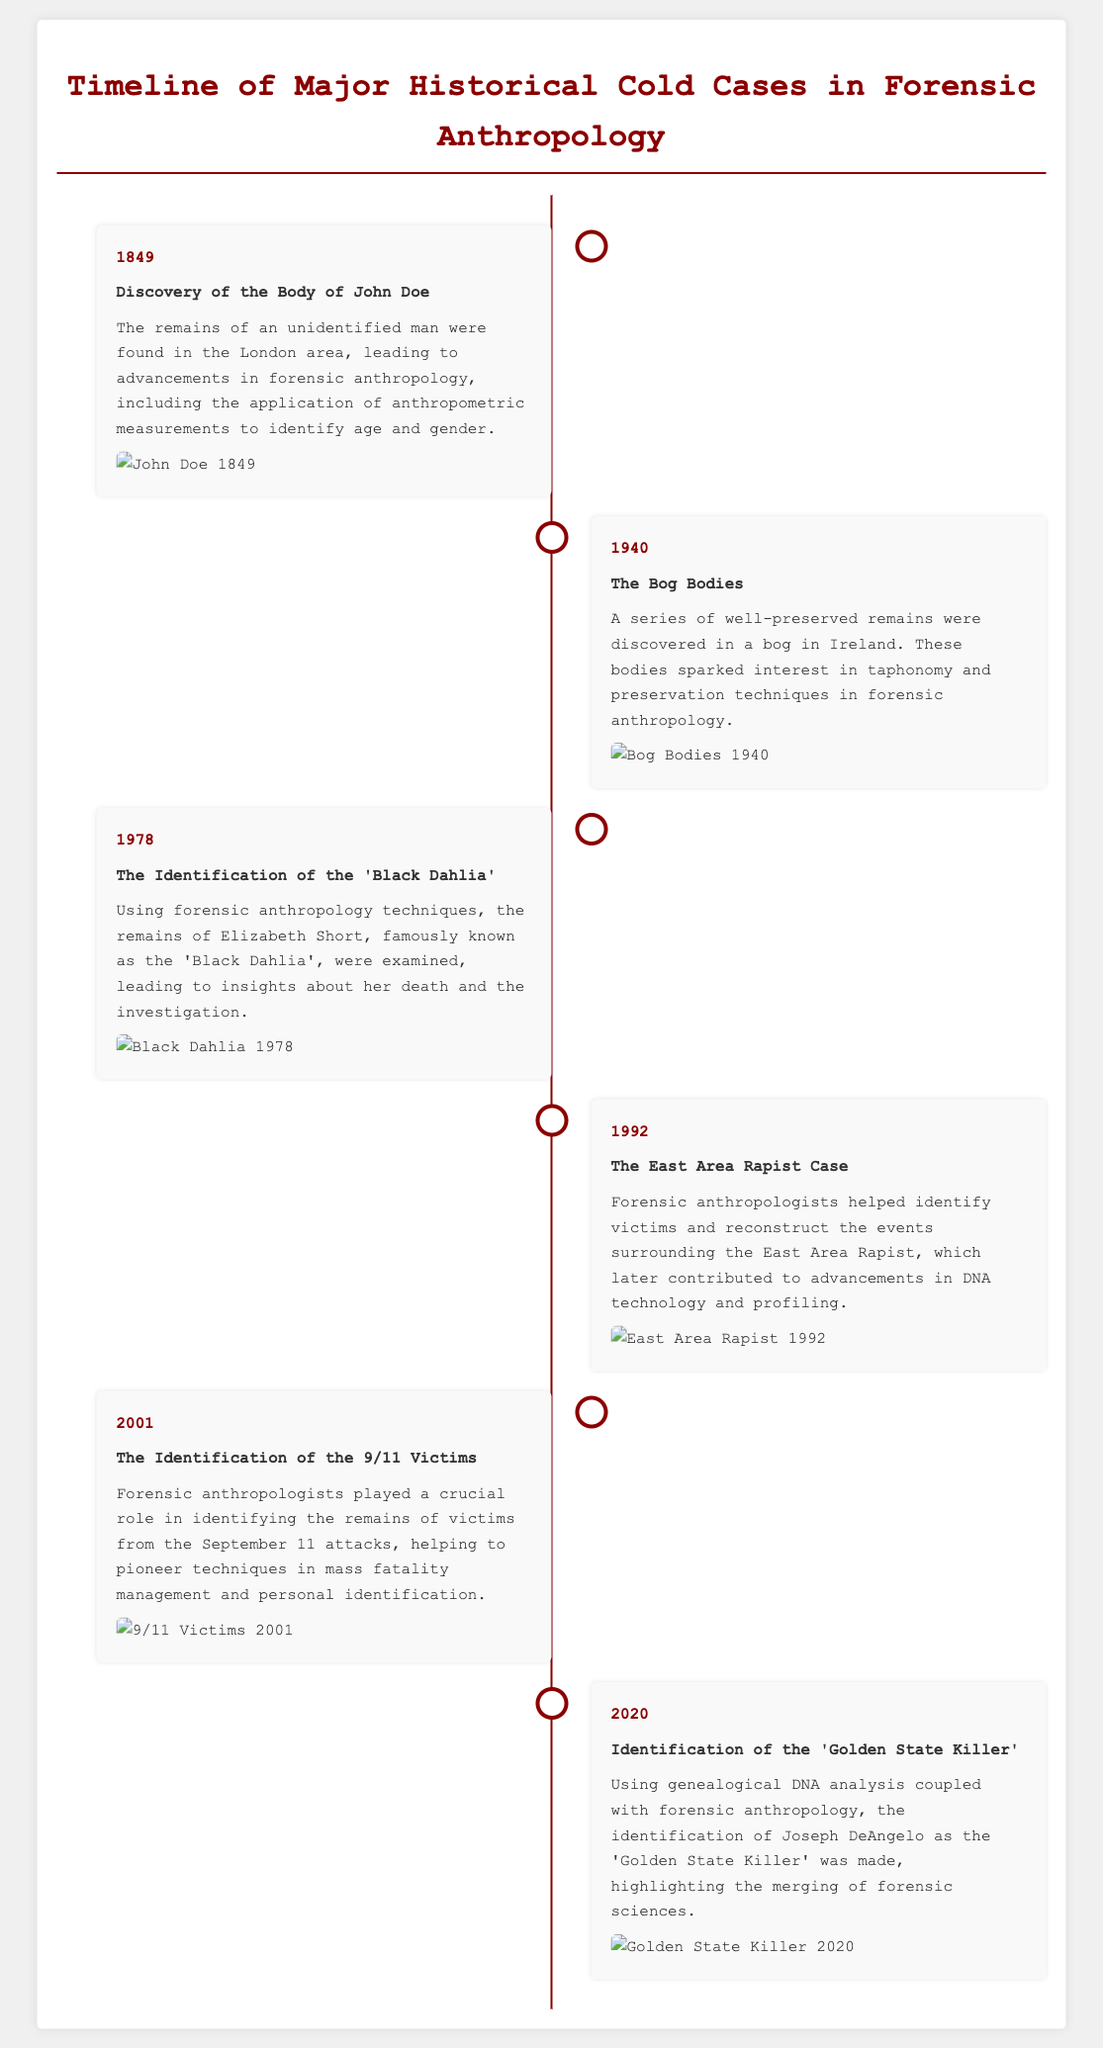What year was the body of John Doe discovered? The document states the discovery of John Doe's remains occurred in 1849.
Answer: 1849 What event is associated with the year 1940? The document mentions 'The Bog Bodies' as the significant event in that year.
Answer: The Bog Bodies Who was identified as the 'Golden State Killer'? The document specifically names Joseph DeAngelo as the identified perpetrator.
Answer: Joseph DeAngelo What forensic anthropology technique was highlighted in the 2001 identification case? The document notes that mass fatality management and personal identification techniques were pioneered.
Answer: Mass fatality management Which cold case relates to the year 1978? The document refers to the identification of the 'Black Dahlia' case for this year.
Answer: 'Black Dahlia' What was discovered in Ireland in 1940? According to the document, well-preserved remains were found in a bog.
Answer: Well-preserved remains How did forensic anthropologists contribute to the East Area Rapist case? The document indicates that they helped identify victims and reconstruct events.
Answer: Identify victims What was a key advancement in forensic anthropology derived from the 9/11 attacks? The document highlights the pioneering of techniques in personal identification.
Answer: Personal identification techniques 